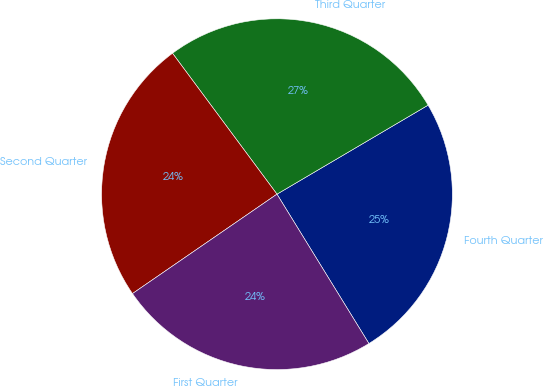Convert chart. <chart><loc_0><loc_0><loc_500><loc_500><pie_chart><fcel>Fourth Quarter<fcel>Third Quarter<fcel>Second Quarter<fcel>First Quarter<nl><fcel>24.69%<fcel>26.68%<fcel>24.44%<fcel>24.19%<nl></chart> 